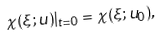Convert formula to latex. <formula><loc_0><loc_0><loc_500><loc_500>\chi ( \xi ; u ) | _ { t = 0 } = \chi ( \xi ; u _ { 0 } ) ,</formula> 